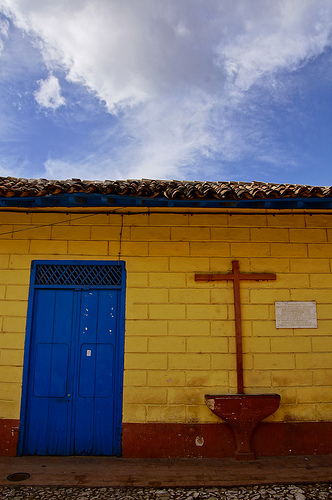<image>
Is there a cross on the door? No. The cross is not positioned on the door. They may be near each other, but the cross is not supported by or resting on top of the door. 